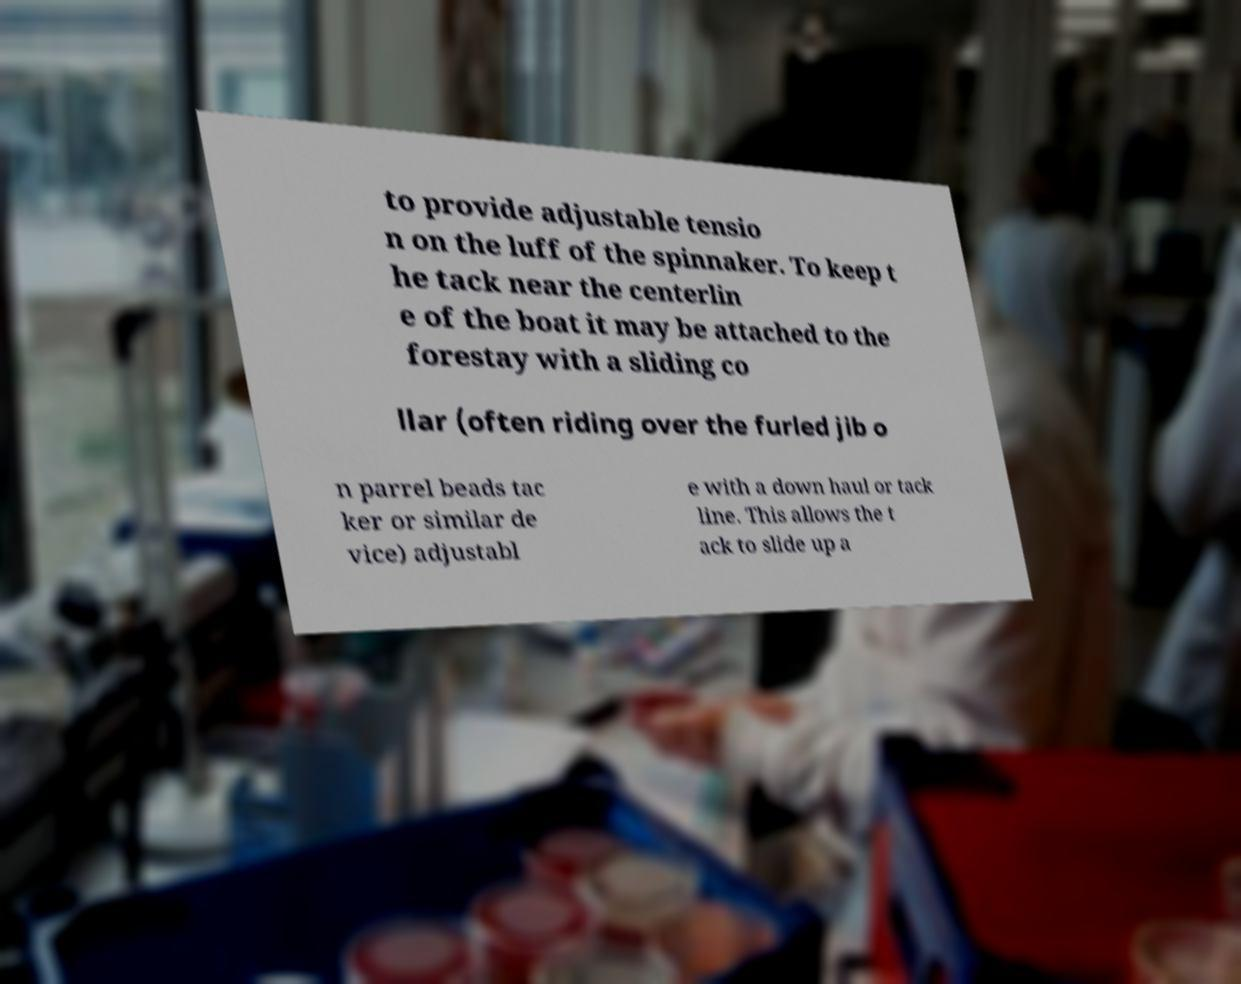Could you extract and type out the text from this image? to provide adjustable tensio n on the luff of the spinnaker. To keep t he tack near the centerlin e of the boat it may be attached to the forestay with a sliding co llar (often riding over the furled jib o n parrel beads tac ker or similar de vice) adjustabl e with a down haul or tack line. This allows the t ack to slide up a 